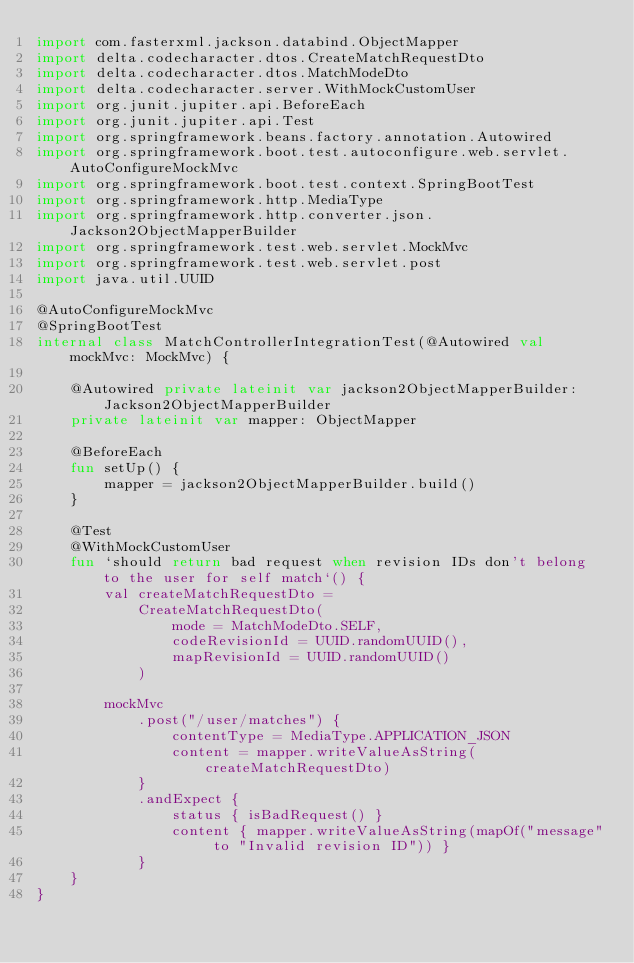<code> <loc_0><loc_0><loc_500><loc_500><_Kotlin_>import com.fasterxml.jackson.databind.ObjectMapper
import delta.codecharacter.dtos.CreateMatchRequestDto
import delta.codecharacter.dtos.MatchModeDto
import delta.codecharacter.server.WithMockCustomUser
import org.junit.jupiter.api.BeforeEach
import org.junit.jupiter.api.Test
import org.springframework.beans.factory.annotation.Autowired
import org.springframework.boot.test.autoconfigure.web.servlet.AutoConfigureMockMvc
import org.springframework.boot.test.context.SpringBootTest
import org.springframework.http.MediaType
import org.springframework.http.converter.json.Jackson2ObjectMapperBuilder
import org.springframework.test.web.servlet.MockMvc
import org.springframework.test.web.servlet.post
import java.util.UUID

@AutoConfigureMockMvc
@SpringBootTest
internal class MatchControllerIntegrationTest(@Autowired val mockMvc: MockMvc) {

    @Autowired private lateinit var jackson2ObjectMapperBuilder: Jackson2ObjectMapperBuilder
    private lateinit var mapper: ObjectMapper

    @BeforeEach
    fun setUp() {
        mapper = jackson2ObjectMapperBuilder.build()
    }

    @Test
    @WithMockCustomUser
    fun `should return bad request when revision IDs don't belong to the user for self match`() {
        val createMatchRequestDto =
            CreateMatchRequestDto(
                mode = MatchModeDto.SELF,
                codeRevisionId = UUID.randomUUID(),
                mapRevisionId = UUID.randomUUID()
            )

        mockMvc
            .post("/user/matches") {
                contentType = MediaType.APPLICATION_JSON
                content = mapper.writeValueAsString(createMatchRequestDto)
            }
            .andExpect {
                status { isBadRequest() }
                content { mapper.writeValueAsString(mapOf("message" to "Invalid revision ID")) }
            }
    }
}
</code> 